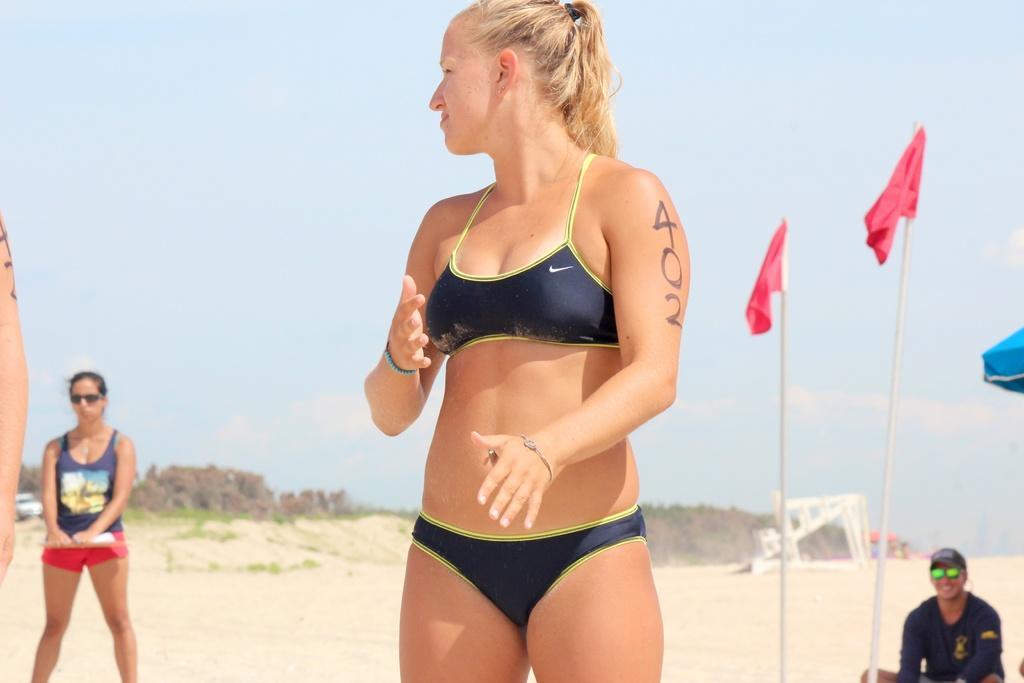Please provide a concise description of this image. In this image we can see people, poles, flags, car, sand, trees, and objects. In the background there is sky with clouds. 